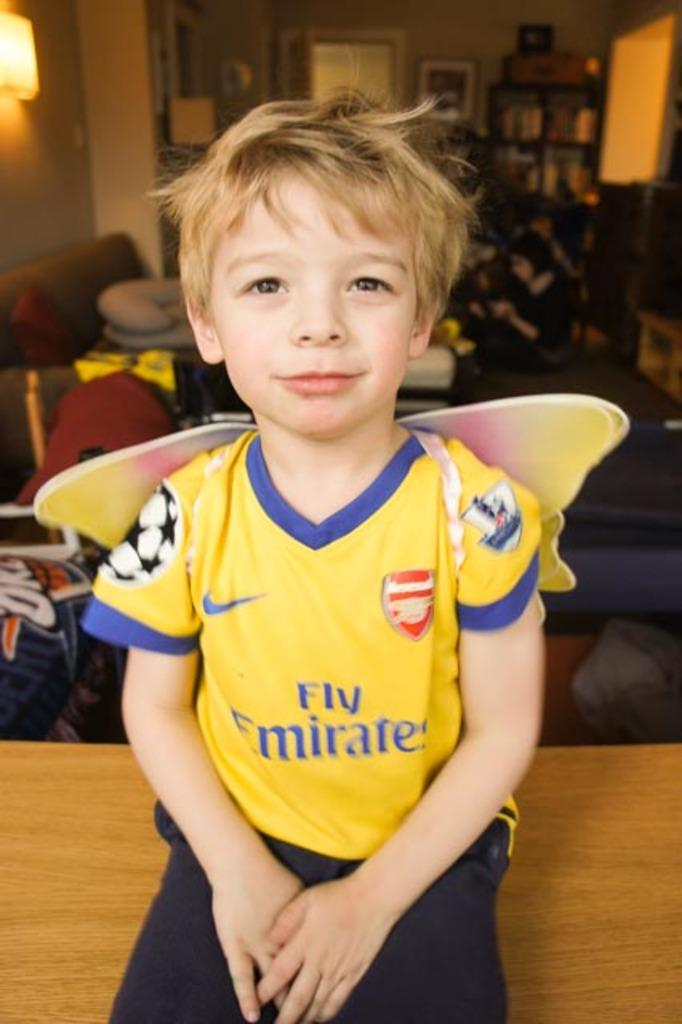<image>
Present a compact description of the photo's key features. small boy wearing yellow fly emirates soccer jersey 